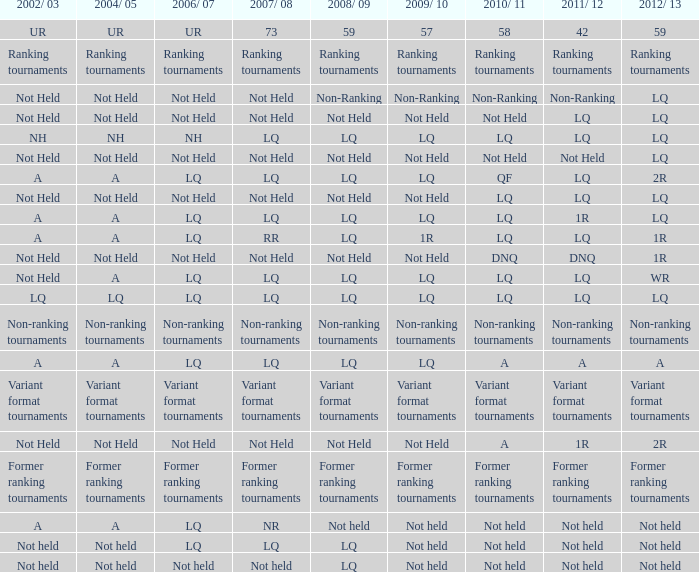Name the 2006/07 with 2011/12 of lq and 2010/11 of lq with 2002/03 of lq LQ. 